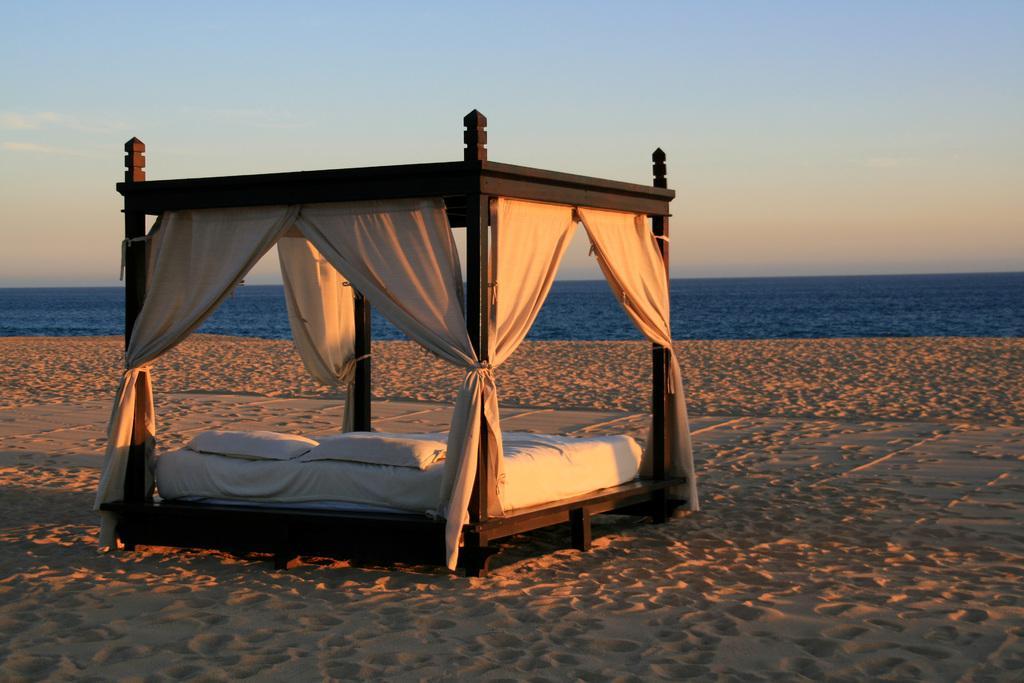Could you give a brief overview of what you see in this image? In this picture, we see the outdoor canopy bed. It has the curtains. At the bottom, we see the sand. In the background, we see water and this water might be in the river or in the oasis. At the top, we see the sky. 